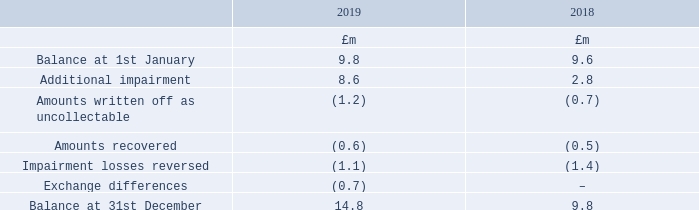The credit risk profile of trade receivables
Other than those disclosed above no other impairment losses on receivables and contract assets arising from contracts with customers have been recognised. Other than trade receivables there are no financial assets that are past their due date at 31st December 2019.
Payment terms across the Group vary dependent on the geographic location of each operating company. Payment is typically due between 20 and 90 days after the invoice is issued.
All contracts with customers do not contain a significant financing component.
The movement in the allowance for impairment in respect of trade receivables during the year was as follows:
How do payment terms across the Group vary? Dependent on the geographic location of each operating company. When is payment typically due for trade receivables? Between 20 and 90 days after the invoice is issued. For which years was the movement in the allowance for impairment in respect of trade receivables during the year recorded? 2019, 2018. In which year was the balance at 1st January larger? 9.8>9.6
Answer: 2019. What was the change in the balance at 31st December in 2019 from 2018?
Answer scale should be: million. 14.8-9.8
Answer: 5. What was the percentage change in the balance at 31st December in 2019 from 2018?
Answer scale should be: percent. (14.8-9.8)/9.8
Answer: 51.02. 